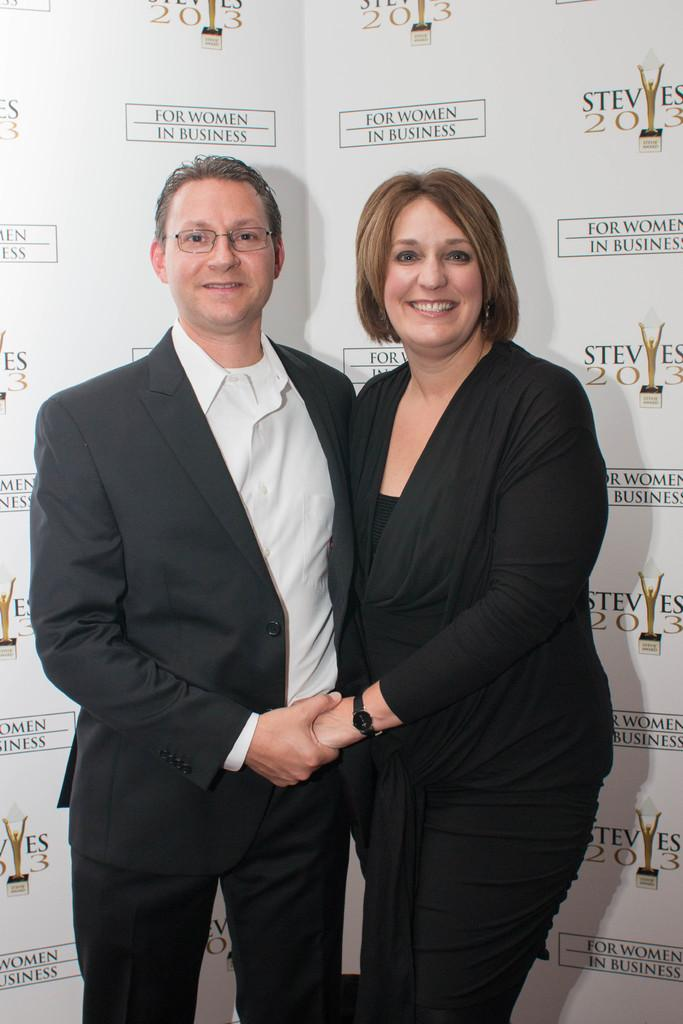How many people are present in the image? There are two persons in the image. What can be seen in the background of the image? There is a banner in the background of the image. What is written or depicted on the banner? The banner contains text and pictures. What type of soap is being used by the persons in the image? There is no soap present in the image; it features two persons and a banner with text and pictures. 